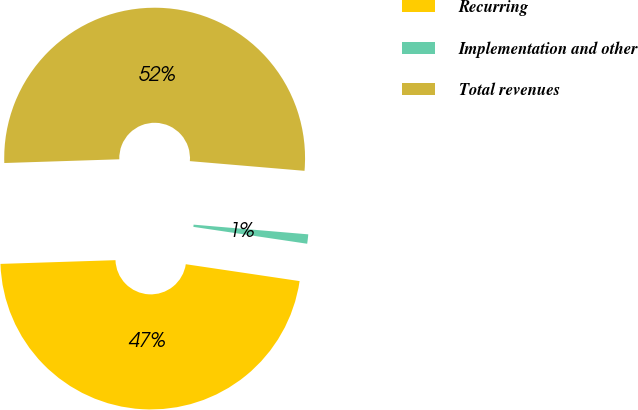Convert chart. <chart><loc_0><loc_0><loc_500><loc_500><pie_chart><fcel>Recurring<fcel>Implementation and other<fcel>Total revenues<nl><fcel>47.14%<fcel>1.0%<fcel>51.86%<nl></chart> 